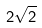Convert formula to latex. <formula><loc_0><loc_0><loc_500><loc_500>2 \sqrt { 2 }</formula> 